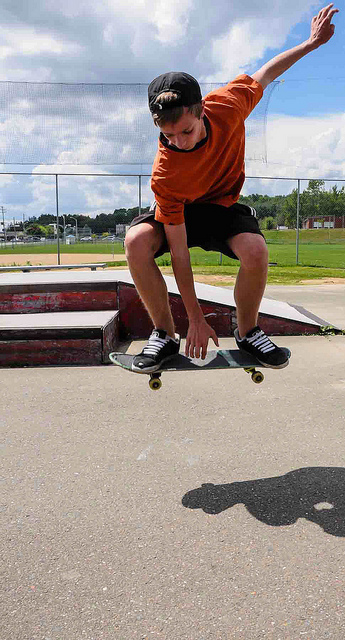How many motorcycles are between the sidewalk and the yellow line in the road? Based on the image provided, there are no motorcycles present between the sidewalk and the yellow line on the road. Instead, the image captures a moment of a person performing a trick with their skateboard at a skatepark. 